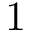<formula> <loc_0><loc_0><loc_500><loc_500>1</formula> 